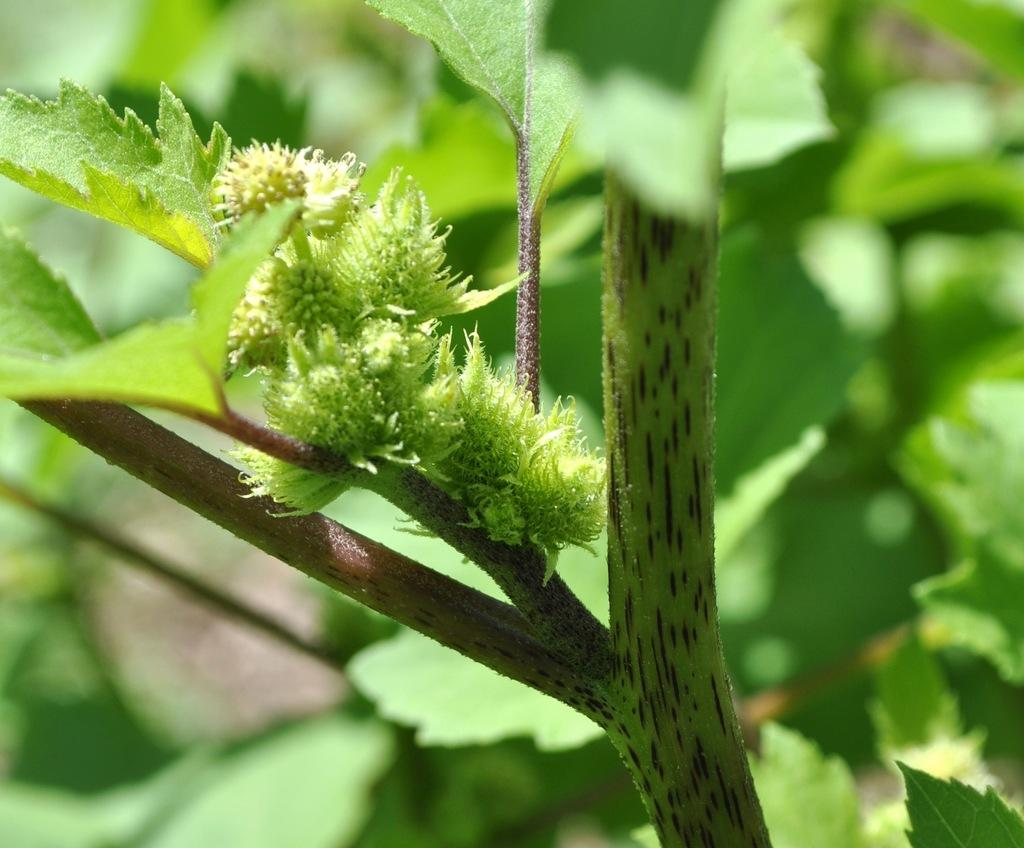What type of vegetation can be seen in the image? There are plants and a tree in the image. Can you describe the background of the image? The background of the image is blurred. What type of wine is being served by the owner in the image? There is no wine or owner present in the image; it features plants and a tree with a blurred background. 